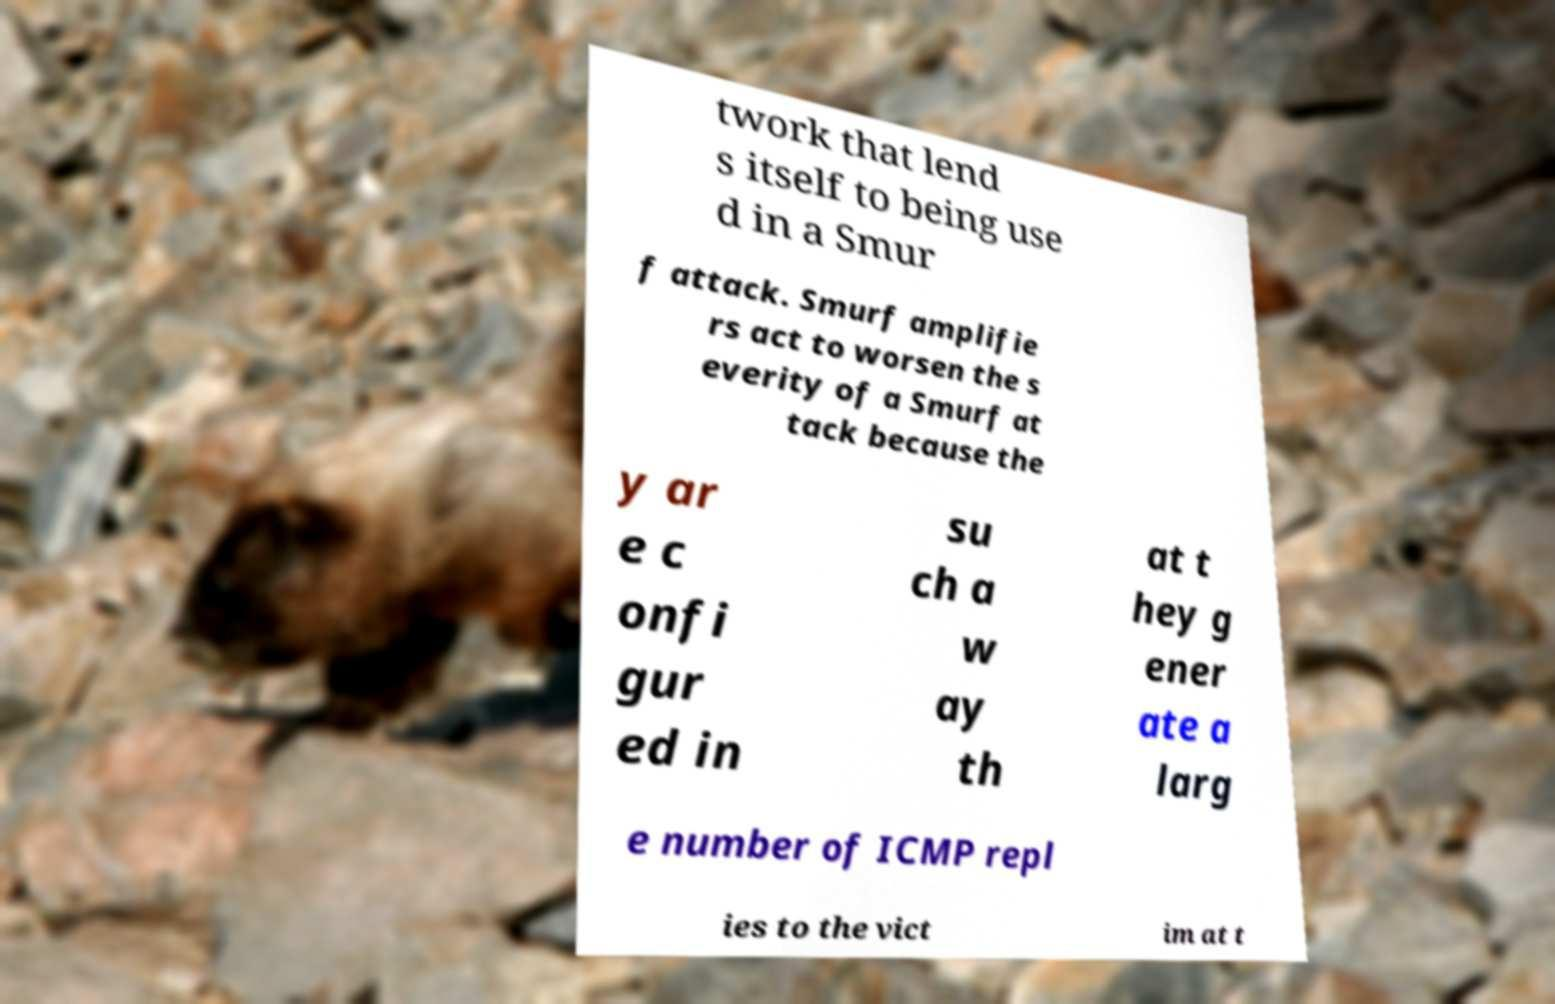Can you read and provide the text displayed in the image?This photo seems to have some interesting text. Can you extract and type it out for me? twork that lend s itself to being use d in a Smur f attack. Smurf amplifie rs act to worsen the s everity of a Smurf at tack because the y ar e c onfi gur ed in su ch a w ay th at t hey g ener ate a larg e number of ICMP repl ies to the vict im at t 